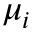<formula> <loc_0><loc_0><loc_500><loc_500>\mu _ { i }</formula> 